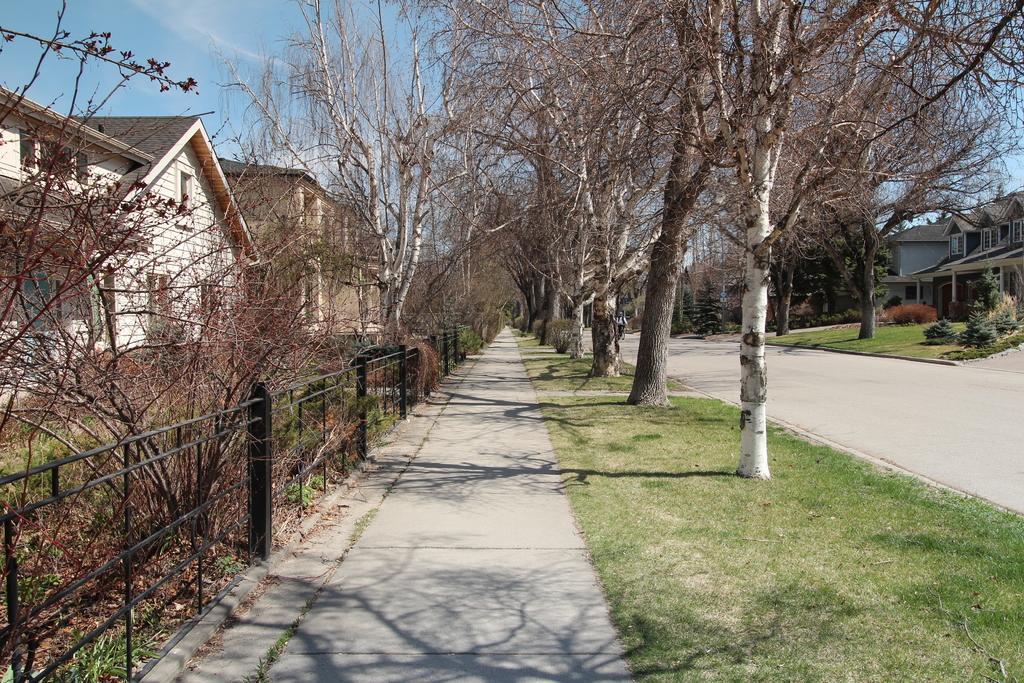How would you summarize this image in a sentence or two? In this picture we can see a vehicle on the road, around we can see some houses, grass, trees and we can see fencing. 